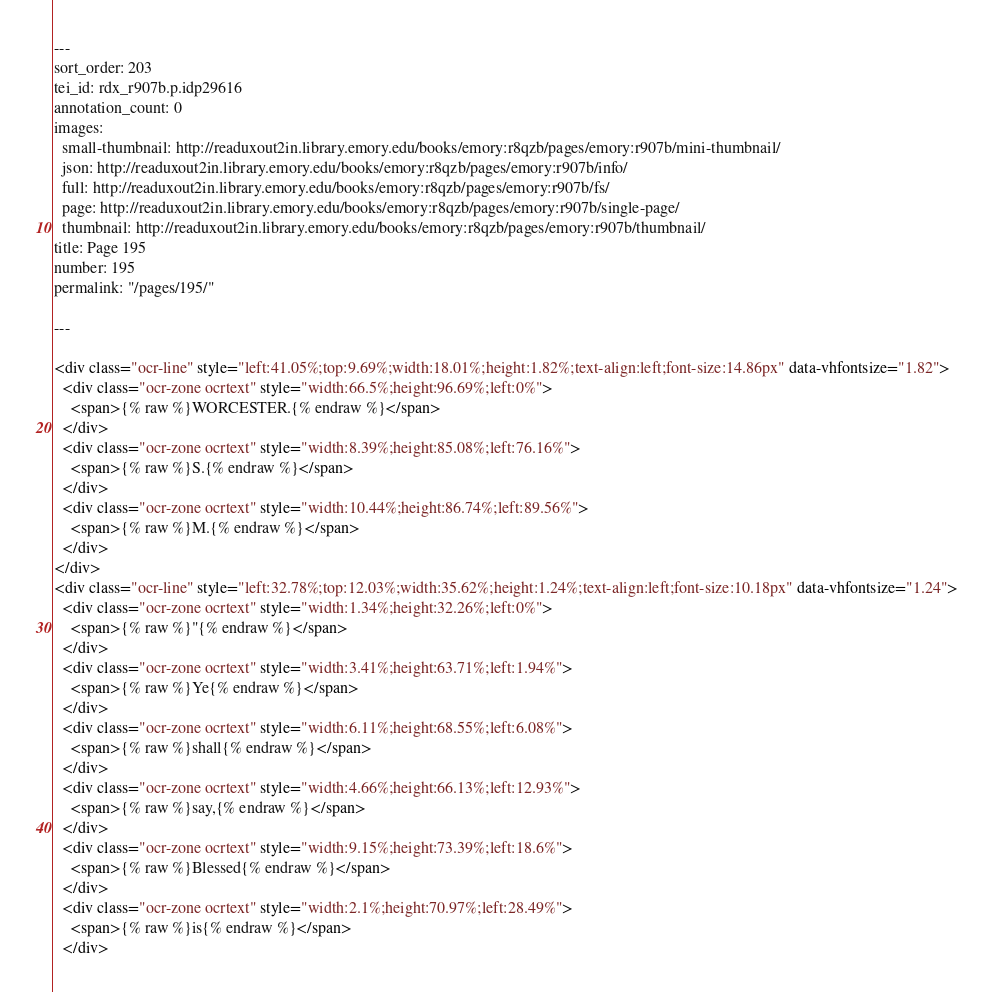<code> <loc_0><loc_0><loc_500><loc_500><_HTML_>---
sort_order: 203
tei_id: rdx_r907b.p.idp29616
annotation_count: 0
images:
  small-thumbnail: http://readuxout2in.library.emory.edu/books/emory:r8qzb/pages/emory:r907b/mini-thumbnail/
  json: http://readuxout2in.library.emory.edu/books/emory:r8qzb/pages/emory:r907b/info/
  full: http://readuxout2in.library.emory.edu/books/emory:r8qzb/pages/emory:r907b/fs/
  page: http://readuxout2in.library.emory.edu/books/emory:r8qzb/pages/emory:r907b/single-page/
  thumbnail: http://readuxout2in.library.emory.edu/books/emory:r8qzb/pages/emory:r907b/thumbnail/
title: Page 195
number: 195
permalink: "/pages/195/"

---

<div class="ocr-line" style="left:41.05%;top:9.69%;width:18.01%;height:1.82%;text-align:left;font-size:14.86px" data-vhfontsize="1.82">
  <div class="ocr-zone ocrtext" style="width:66.5%;height:96.69%;left:0%">
    <span>{% raw %}WORCESTER.{% endraw %}</span>
  </div>
  <div class="ocr-zone ocrtext" style="width:8.39%;height:85.08%;left:76.16%">
    <span>{% raw %}S.{% endraw %}</span>
  </div>
  <div class="ocr-zone ocrtext" style="width:10.44%;height:86.74%;left:89.56%">
    <span>{% raw %}M.{% endraw %}</span>
  </div>
</div>
<div class="ocr-line" style="left:32.78%;top:12.03%;width:35.62%;height:1.24%;text-align:left;font-size:10.18px" data-vhfontsize="1.24">
  <div class="ocr-zone ocrtext" style="width:1.34%;height:32.26%;left:0%">
    <span>{% raw %}"{% endraw %}</span>
  </div>
  <div class="ocr-zone ocrtext" style="width:3.41%;height:63.71%;left:1.94%">
    <span>{% raw %}Ye{% endraw %}</span>
  </div>
  <div class="ocr-zone ocrtext" style="width:6.11%;height:68.55%;left:6.08%">
    <span>{% raw %}shall{% endraw %}</span>
  </div>
  <div class="ocr-zone ocrtext" style="width:4.66%;height:66.13%;left:12.93%">
    <span>{% raw %}say,{% endraw %}</span>
  </div>
  <div class="ocr-zone ocrtext" style="width:9.15%;height:73.39%;left:18.6%">
    <span>{% raw %}Blessed{% endraw %}</span>
  </div>
  <div class="ocr-zone ocrtext" style="width:2.1%;height:70.97%;left:28.49%">
    <span>{% raw %}is{% endraw %}</span>
  </div></code> 